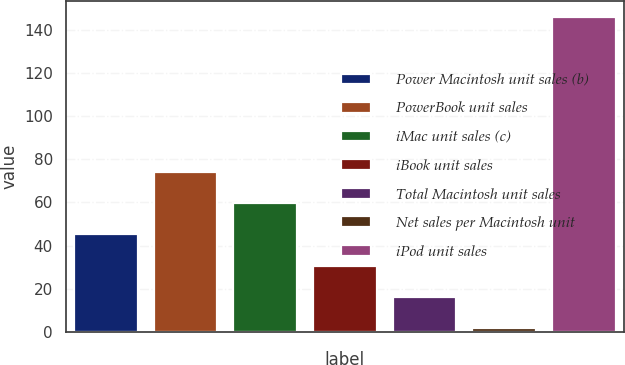Convert chart. <chart><loc_0><loc_0><loc_500><loc_500><bar_chart><fcel>Power Macintosh unit sales (b)<fcel>PowerBook unit sales<fcel>iMac unit sales (c)<fcel>iBook unit sales<fcel>Total Macintosh unit sales<fcel>Net sales per Macintosh unit<fcel>iPod unit sales<nl><fcel>45.2<fcel>74<fcel>59.6<fcel>30.8<fcel>16.4<fcel>2<fcel>146<nl></chart> 